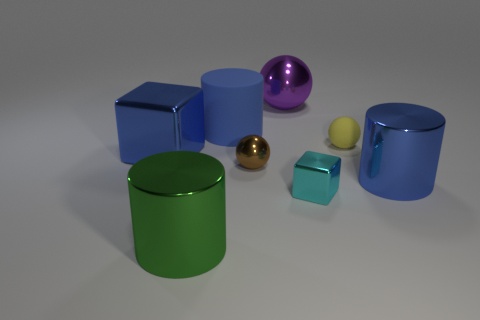Add 1 cylinders. How many objects exist? 9 Subtract all cylinders. How many objects are left? 5 Subtract 0 gray cubes. How many objects are left? 8 Subtract all brown metal spheres. Subtract all matte cylinders. How many objects are left? 6 Add 5 cylinders. How many cylinders are left? 8 Add 7 big green matte objects. How many big green matte objects exist? 7 